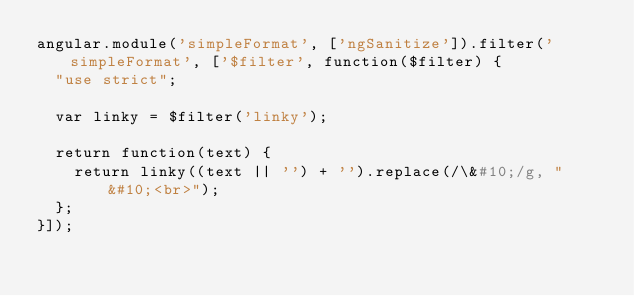Convert code to text. <code><loc_0><loc_0><loc_500><loc_500><_JavaScript_>angular.module('simpleFormat', ['ngSanitize']).filter('simpleFormat', ['$filter', function($filter) {
  "use strict";

  var linky = $filter('linky');

  return function(text) {
    return linky((text || '') + '').replace(/\&#10;/g, "&#10;<br>");
  };
}]);
</code> 